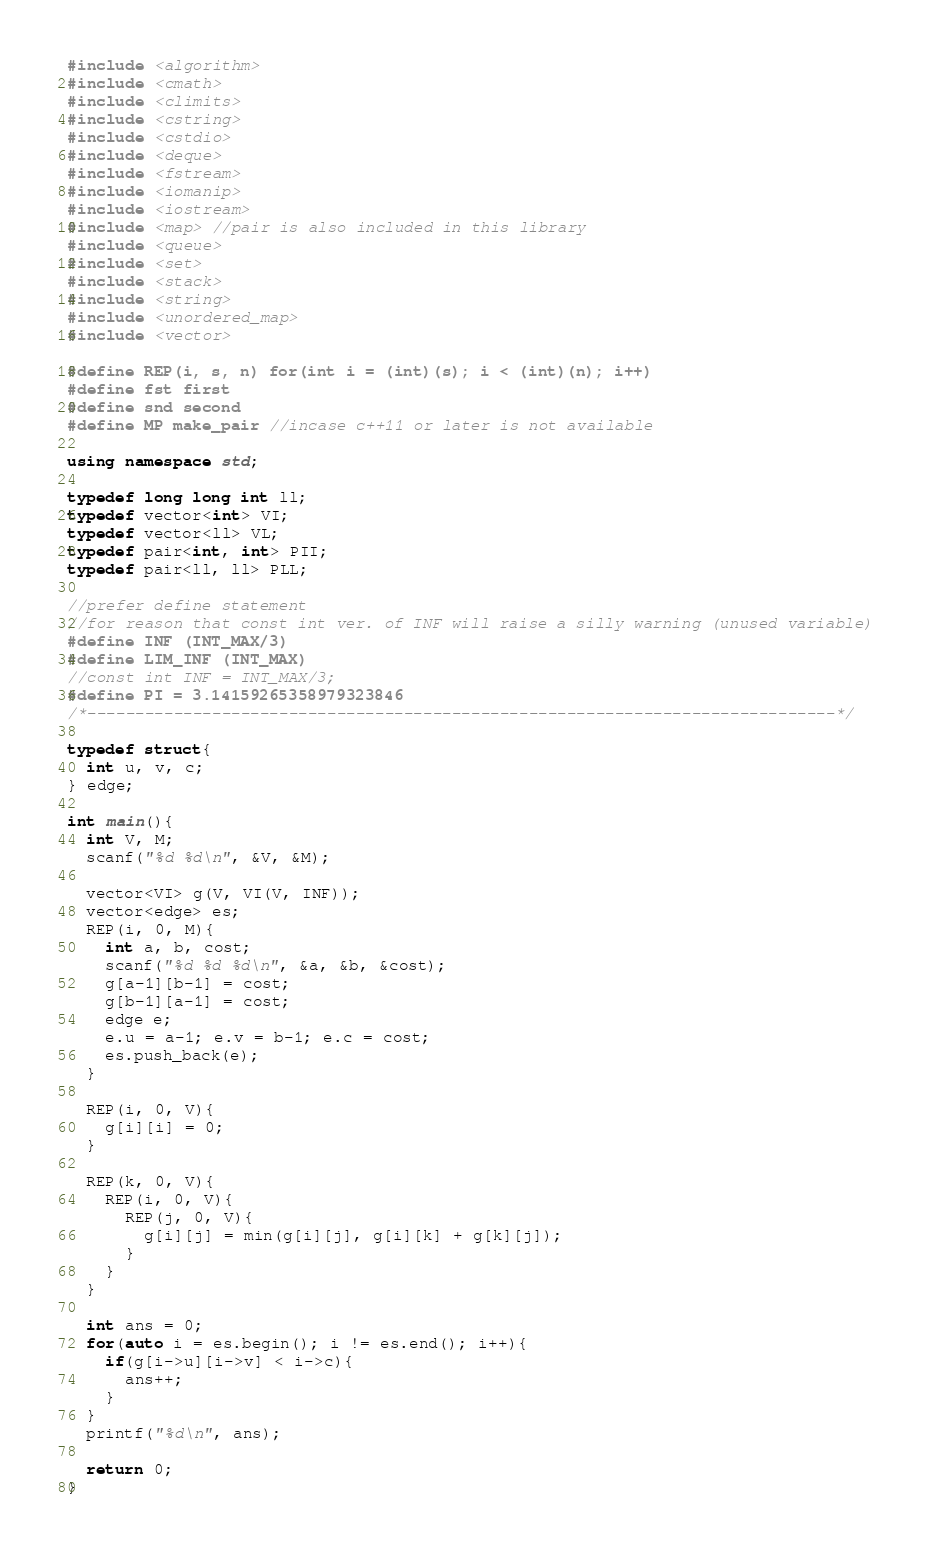<code> <loc_0><loc_0><loc_500><loc_500><_C++_>#include <algorithm>
#include <cmath>
#include <climits>
#include <cstring>
#include <cstdio>
#include <deque>
#include <fstream>
#include <iomanip>
#include <iostream>
#include <map> //pair is also included in this library
#include <queue>
#include <set>
#include <stack>
#include <string>
#include <unordered_map>
#include <vector>

#define REP(i, s, n) for(int i = (int)(s); i < (int)(n); i++)
#define fst first
#define snd second
#define MP make_pair //incase c++11 or later is not available

using namespace std;

typedef long long int ll;
typedef vector<int> VI;
typedef vector<ll> VL;
typedef pair<int, int> PII;
typedef pair<ll, ll> PLL;

//prefer define statement
//for reason that const int ver. of INF will raise a silly warning (unused variable)
#define INF (INT_MAX/3)
#define LIM_INF (INT_MAX)
//const int INF = INT_MAX/3;
#define PI = 3.14159265358979323846
/*------------------------------------------------------------------------------*/

typedef struct{
  int u, v, c;
} edge;

int main(){
  int V, M;
  scanf("%d %d\n", &V, &M);

  vector<VI> g(V, VI(V, INF));
  vector<edge> es;
  REP(i, 0, M){
    int a, b, cost;
    scanf("%d %d %d\n", &a, &b, &cost);
    g[a-1][b-1] = cost;
    g[b-1][a-1] = cost;
    edge e;
    e.u = a-1; e.v = b-1; e.c = cost;
    es.push_back(e);
  }

  REP(i, 0, V){
    g[i][i] = 0;
  }

  REP(k, 0, V){
    REP(i, 0, V){
      REP(j, 0, V){
        g[i][j] = min(g[i][j], g[i][k] + g[k][j]);
      }
    }
  }

  int ans = 0;
  for(auto i = es.begin(); i != es.end(); i++){
    if(g[i->u][i->v] < i->c){
      ans++;
    }
  }
  printf("%d\n", ans);

  return 0;
}
</code> 